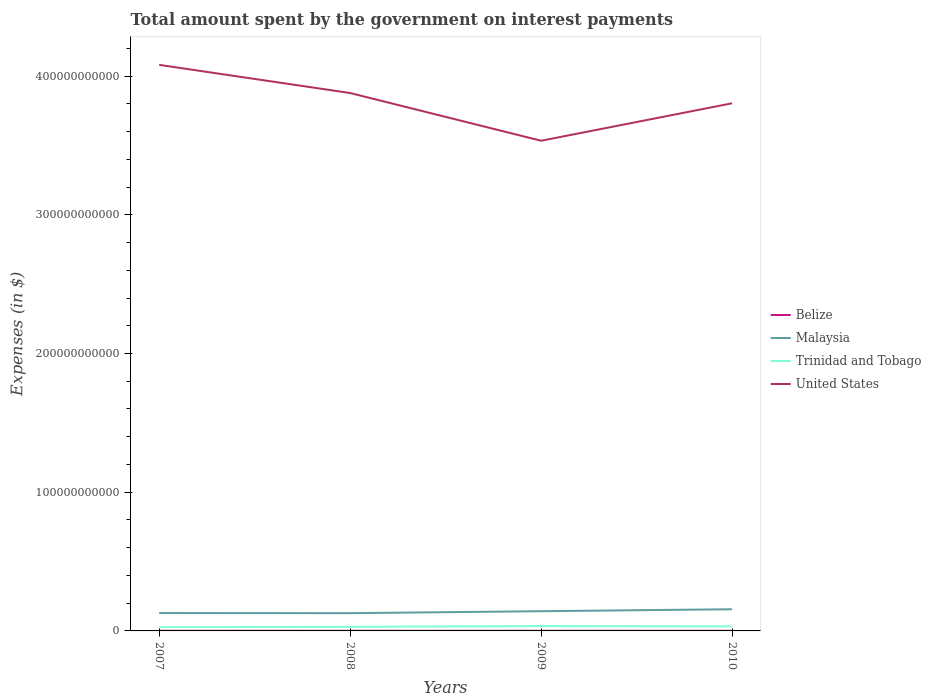Is the number of lines equal to the number of legend labels?
Ensure brevity in your answer.  Yes. Across all years, what is the maximum amount spent on interest payments by the government in Trinidad and Tobago?
Your answer should be very brief. 2.70e+09. In which year was the amount spent on interest payments by the government in United States maximum?
Offer a terse response. 2009. What is the total amount spent on interest payments by the government in Malaysia in the graph?
Provide a succinct answer. -1.31e+09. What is the difference between the highest and the second highest amount spent on interest payments by the government in United States?
Keep it short and to the point. 5.47e+1. Is the amount spent on interest payments by the government in Trinidad and Tobago strictly greater than the amount spent on interest payments by the government in Malaysia over the years?
Give a very brief answer. Yes. How many years are there in the graph?
Your answer should be compact. 4. What is the difference between two consecutive major ticks on the Y-axis?
Give a very brief answer. 1.00e+11. Does the graph contain any zero values?
Provide a succinct answer. No. Where does the legend appear in the graph?
Keep it short and to the point. Center right. How many legend labels are there?
Offer a very short reply. 4. What is the title of the graph?
Make the answer very short. Total amount spent by the government on interest payments. What is the label or title of the Y-axis?
Offer a very short reply. Expenses (in $). What is the Expenses (in $) in Belize in 2007?
Provide a short and direct response. 1.11e+08. What is the Expenses (in $) in Malaysia in 2007?
Your answer should be very brief. 1.29e+1. What is the Expenses (in $) of Trinidad and Tobago in 2007?
Keep it short and to the point. 2.70e+09. What is the Expenses (in $) of United States in 2007?
Offer a very short reply. 4.08e+11. What is the Expenses (in $) in Belize in 2008?
Your answer should be compact. 1.02e+08. What is the Expenses (in $) of Malaysia in 2008?
Offer a very short reply. 1.28e+1. What is the Expenses (in $) of Trinidad and Tobago in 2008?
Offer a terse response. 2.97e+09. What is the Expenses (in $) of United States in 2008?
Provide a short and direct response. 3.88e+11. What is the Expenses (in $) of Belize in 2009?
Your response must be concise. 9.58e+07. What is the Expenses (in $) in Malaysia in 2009?
Make the answer very short. 1.42e+1. What is the Expenses (in $) of Trinidad and Tobago in 2009?
Your answer should be compact. 3.50e+09. What is the Expenses (in $) in United States in 2009?
Keep it short and to the point. 3.53e+11. What is the Expenses (in $) in Belize in 2010?
Offer a terse response. 1.03e+08. What is the Expenses (in $) in Malaysia in 2010?
Provide a succinct answer. 1.56e+1. What is the Expenses (in $) of Trinidad and Tobago in 2010?
Your answer should be compact. 3.29e+09. What is the Expenses (in $) in United States in 2010?
Provide a short and direct response. 3.80e+11. Across all years, what is the maximum Expenses (in $) of Belize?
Make the answer very short. 1.11e+08. Across all years, what is the maximum Expenses (in $) of Malaysia?
Keep it short and to the point. 1.56e+1. Across all years, what is the maximum Expenses (in $) of Trinidad and Tobago?
Your response must be concise. 3.50e+09. Across all years, what is the maximum Expenses (in $) in United States?
Make the answer very short. 4.08e+11. Across all years, what is the minimum Expenses (in $) in Belize?
Give a very brief answer. 9.58e+07. Across all years, what is the minimum Expenses (in $) in Malaysia?
Your response must be concise. 1.28e+1. Across all years, what is the minimum Expenses (in $) of Trinidad and Tobago?
Keep it short and to the point. 2.70e+09. Across all years, what is the minimum Expenses (in $) in United States?
Ensure brevity in your answer.  3.53e+11. What is the total Expenses (in $) of Belize in the graph?
Provide a succinct answer. 4.13e+08. What is the total Expenses (in $) of Malaysia in the graph?
Offer a terse response. 5.56e+1. What is the total Expenses (in $) of Trinidad and Tobago in the graph?
Make the answer very short. 1.25e+1. What is the total Expenses (in $) of United States in the graph?
Provide a short and direct response. 1.53e+12. What is the difference between the Expenses (in $) in Belize in 2007 and that in 2008?
Give a very brief answer. 8.84e+06. What is the difference between the Expenses (in $) of Malaysia in 2007 and that in 2008?
Your answer should be very brief. 1.14e+08. What is the difference between the Expenses (in $) in Trinidad and Tobago in 2007 and that in 2008?
Make the answer very short. -2.69e+08. What is the difference between the Expenses (in $) of United States in 2007 and that in 2008?
Your answer should be very brief. 2.03e+1. What is the difference between the Expenses (in $) of Belize in 2007 and that in 2009?
Offer a terse response. 1.54e+07. What is the difference between the Expenses (in $) in Malaysia in 2007 and that in 2009?
Ensure brevity in your answer.  -1.31e+09. What is the difference between the Expenses (in $) in Trinidad and Tobago in 2007 and that in 2009?
Provide a short and direct response. -8.02e+08. What is the difference between the Expenses (in $) in United States in 2007 and that in 2009?
Offer a terse response. 5.47e+1. What is the difference between the Expenses (in $) of Belize in 2007 and that in 2010?
Your answer should be very brief. 7.81e+06. What is the difference between the Expenses (in $) of Malaysia in 2007 and that in 2010?
Provide a succinct answer. -2.71e+09. What is the difference between the Expenses (in $) in Trinidad and Tobago in 2007 and that in 2010?
Your response must be concise. -5.92e+08. What is the difference between the Expenses (in $) in United States in 2007 and that in 2010?
Give a very brief answer. 2.77e+1. What is the difference between the Expenses (in $) of Belize in 2008 and that in 2009?
Your response must be concise. 6.55e+06. What is the difference between the Expenses (in $) of Malaysia in 2008 and that in 2009?
Your answer should be very brief. -1.42e+09. What is the difference between the Expenses (in $) of Trinidad and Tobago in 2008 and that in 2009?
Give a very brief answer. -5.33e+08. What is the difference between the Expenses (in $) of United States in 2008 and that in 2009?
Your answer should be very brief. 3.44e+1. What is the difference between the Expenses (in $) in Belize in 2008 and that in 2010?
Make the answer very short. -1.03e+06. What is the difference between the Expenses (in $) of Malaysia in 2008 and that in 2010?
Your answer should be compact. -2.82e+09. What is the difference between the Expenses (in $) of Trinidad and Tobago in 2008 and that in 2010?
Offer a terse response. -3.23e+08. What is the difference between the Expenses (in $) of United States in 2008 and that in 2010?
Your response must be concise. 7.40e+09. What is the difference between the Expenses (in $) in Belize in 2009 and that in 2010?
Offer a very short reply. -7.59e+06. What is the difference between the Expenses (in $) in Malaysia in 2009 and that in 2010?
Make the answer very short. -1.40e+09. What is the difference between the Expenses (in $) of Trinidad and Tobago in 2009 and that in 2010?
Your response must be concise. 2.10e+08. What is the difference between the Expenses (in $) in United States in 2009 and that in 2010?
Offer a terse response. -2.70e+1. What is the difference between the Expenses (in $) in Belize in 2007 and the Expenses (in $) in Malaysia in 2008?
Ensure brevity in your answer.  -1.27e+1. What is the difference between the Expenses (in $) in Belize in 2007 and the Expenses (in $) in Trinidad and Tobago in 2008?
Give a very brief answer. -2.86e+09. What is the difference between the Expenses (in $) of Belize in 2007 and the Expenses (in $) of United States in 2008?
Your response must be concise. -3.88e+11. What is the difference between the Expenses (in $) of Malaysia in 2007 and the Expenses (in $) of Trinidad and Tobago in 2008?
Offer a terse response. 9.94e+09. What is the difference between the Expenses (in $) of Malaysia in 2007 and the Expenses (in $) of United States in 2008?
Give a very brief answer. -3.75e+11. What is the difference between the Expenses (in $) in Trinidad and Tobago in 2007 and the Expenses (in $) in United States in 2008?
Provide a short and direct response. -3.85e+11. What is the difference between the Expenses (in $) in Belize in 2007 and the Expenses (in $) in Malaysia in 2009?
Your answer should be compact. -1.41e+1. What is the difference between the Expenses (in $) in Belize in 2007 and the Expenses (in $) in Trinidad and Tobago in 2009?
Give a very brief answer. -3.39e+09. What is the difference between the Expenses (in $) in Belize in 2007 and the Expenses (in $) in United States in 2009?
Provide a short and direct response. -3.53e+11. What is the difference between the Expenses (in $) of Malaysia in 2007 and the Expenses (in $) of Trinidad and Tobago in 2009?
Your response must be concise. 9.41e+09. What is the difference between the Expenses (in $) of Malaysia in 2007 and the Expenses (in $) of United States in 2009?
Your answer should be very brief. -3.40e+11. What is the difference between the Expenses (in $) in Trinidad and Tobago in 2007 and the Expenses (in $) in United States in 2009?
Offer a terse response. -3.51e+11. What is the difference between the Expenses (in $) in Belize in 2007 and the Expenses (in $) in Malaysia in 2010?
Offer a very short reply. -1.55e+1. What is the difference between the Expenses (in $) of Belize in 2007 and the Expenses (in $) of Trinidad and Tobago in 2010?
Provide a succinct answer. -3.18e+09. What is the difference between the Expenses (in $) in Belize in 2007 and the Expenses (in $) in United States in 2010?
Offer a very short reply. -3.80e+11. What is the difference between the Expenses (in $) in Malaysia in 2007 and the Expenses (in $) in Trinidad and Tobago in 2010?
Offer a very short reply. 9.62e+09. What is the difference between the Expenses (in $) in Malaysia in 2007 and the Expenses (in $) in United States in 2010?
Your answer should be compact. -3.67e+11. What is the difference between the Expenses (in $) of Trinidad and Tobago in 2007 and the Expenses (in $) of United States in 2010?
Provide a succinct answer. -3.78e+11. What is the difference between the Expenses (in $) of Belize in 2008 and the Expenses (in $) of Malaysia in 2009?
Offer a terse response. -1.41e+1. What is the difference between the Expenses (in $) in Belize in 2008 and the Expenses (in $) in Trinidad and Tobago in 2009?
Give a very brief answer. -3.40e+09. What is the difference between the Expenses (in $) of Belize in 2008 and the Expenses (in $) of United States in 2009?
Your answer should be very brief. -3.53e+11. What is the difference between the Expenses (in $) in Malaysia in 2008 and the Expenses (in $) in Trinidad and Tobago in 2009?
Offer a terse response. 9.30e+09. What is the difference between the Expenses (in $) of Malaysia in 2008 and the Expenses (in $) of United States in 2009?
Your response must be concise. -3.41e+11. What is the difference between the Expenses (in $) of Trinidad and Tobago in 2008 and the Expenses (in $) of United States in 2009?
Ensure brevity in your answer.  -3.50e+11. What is the difference between the Expenses (in $) of Belize in 2008 and the Expenses (in $) of Malaysia in 2010?
Offer a very short reply. -1.55e+1. What is the difference between the Expenses (in $) in Belize in 2008 and the Expenses (in $) in Trinidad and Tobago in 2010?
Your answer should be very brief. -3.19e+09. What is the difference between the Expenses (in $) of Belize in 2008 and the Expenses (in $) of United States in 2010?
Keep it short and to the point. -3.80e+11. What is the difference between the Expenses (in $) of Malaysia in 2008 and the Expenses (in $) of Trinidad and Tobago in 2010?
Provide a succinct answer. 9.51e+09. What is the difference between the Expenses (in $) in Malaysia in 2008 and the Expenses (in $) in United States in 2010?
Make the answer very short. -3.68e+11. What is the difference between the Expenses (in $) of Trinidad and Tobago in 2008 and the Expenses (in $) of United States in 2010?
Offer a very short reply. -3.77e+11. What is the difference between the Expenses (in $) in Belize in 2009 and the Expenses (in $) in Malaysia in 2010?
Give a very brief answer. -1.55e+1. What is the difference between the Expenses (in $) in Belize in 2009 and the Expenses (in $) in Trinidad and Tobago in 2010?
Your answer should be very brief. -3.19e+09. What is the difference between the Expenses (in $) of Belize in 2009 and the Expenses (in $) of United States in 2010?
Provide a succinct answer. -3.80e+11. What is the difference between the Expenses (in $) in Malaysia in 2009 and the Expenses (in $) in Trinidad and Tobago in 2010?
Your answer should be very brief. 1.09e+1. What is the difference between the Expenses (in $) of Malaysia in 2009 and the Expenses (in $) of United States in 2010?
Provide a short and direct response. -3.66e+11. What is the difference between the Expenses (in $) of Trinidad and Tobago in 2009 and the Expenses (in $) of United States in 2010?
Keep it short and to the point. -3.77e+11. What is the average Expenses (in $) in Belize per year?
Keep it short and to the point. 1.03e+08. What is the average Expenses (in $) of Malaysia per year?
Give a very brief answer. 1.39e+1. What is the average Expenses (in $) of Trinidad and Tobago per year?
Keep it short and to the point. 3.11e+09. What is the average Expenses (in $) in United States per year?
Your answer should be compact. 3.82e+11. In the year 2007, what is the difference between the Expenses (in $) of Belize and Expenses (in $) of Malaysia?
Give a very brief answer. -1.28e+1. In the year 2007, what is the difference between the Expenses (in $) in Belize and Expenses (in $) in Trinidad and Tobago?
Your response must be concise. -2.59e+09. In the year 2007, what is the difference between the Expenses (in $) of Belize and Expenses (in $) of United States?
Keep it short and to the point. -4.08e+11. In the year 2007, what is the difference between the Expenses (in $) in Malaysia and Expenses (in $) in Trinidad and Tobago?
Make the answer very short. 1.02e+1. In the year 2007, what is the difference between the Expenses (in $) of Malaysia and Expenses (in $) of United States?
Keep it short and to the point. -3.95e+11. In the year 2007, what is the difference between the Expenses (in $) of Trinidad and Tobago and Expenses (in $) of United States?
Provide a short and direct response. -4.05e+11. In the year 2008, what is the difference between the Expenses (in $) in Belize and Expenses (in $) in Malaysia?
Provide a succinct answer. -1.27e+1. In the year 2008, what is the difference between the Expenses (in $) in Belize and Expenses (in $) in Trinidad and Tobago?
Your answer should be very brief. -2.86e+09. In the year 2008, what is the difference between the Expenses (in $) of Belize and Expenses (in $) of United States?
Offer a very short reply. -3.88e+11. In the year 2008, what is the difference between the Expenses (in $) in Malaysia and Expenses (in $) in Trinidad and Tobago?
Your answer should be very brief. 9.83e+09. In the year 2008, what is the difference between the Expenses (in $) in Malaysia and Expenses (in $) in United States?
Give a very brief answer. -3.75e+11. In the year 2008, what is the difference between the Expenses (in $) of Trinidad and Tobago and Expenses (in $) of United States?
Offer a very short reply. -3.85e+11. In the year 2009, what is the difference between the Expenses (in $) in Belize and Expenses (in $) in Malaysia?
Your answer should be very brief. -1.41e+1. In the year 2009, what is the difference between the Expenses (in $) of Belize and Expenses (in $) of Trinidad and Tobago?
Make the answer very short. -3.40e+09. In the year 2009, what is the difference between the Expenses (in $) of Belize and Expenses (in $) of United States?
Make the answer very short. -3.53e+11. In the year 2009, what is the difference between the Expenses (in $) in Malaysia and Expenses (in $) in Trinidad and Tobago?
Keep it short and to the point. 1.07e+1. In the year 2009, what is the difference between the Expenses (in $) in Malaysia and Expenses (in $) in United States?
Make the answer very short. -3.39e+11. In the year 2009, what is the difference between the Expenses (in $) of Trinidad and Tobago and Expenses (in $) of United States?
Your answer should be very brief. -3.50e+11. In the year 2010, what is the difference between the Expenses (in $) of Belize and Expenses (in $) of Malaysia?
Offer a terse response. -1.55e+1. In the year 2010, what is the difference between the Expenses (in $) in Belize and Expenses (in $) in Trinidad and Tobago?
Make the answer very short. -3.19e+09. In the year 2010, what is the difference between the Expenses (in $) of Belize and Expenses (in $) of United States?
Your response must be concise. -3.80e+11. In the year 2010, what is the difference between the Expenses (in $) of Malaysia and Expenses (in $) of Trinidad and Tobago?
Keep it short and to the point. 1.23e+1. In the year 2010, what is the difference between the Expenses (in $) in Malaysia and Expenses (in $) in United States?
Offer a terse response. -3.65e+11. In the year 2010, what is the difference between the Expenses (in $) of Trinidad and Tobago and Expenses (in $) of United States?
Provide a succinct answer. -3.77e+11. What is the ratio of the Expenses (in $) of Belize in 2007 to that in 2008?
Offer a terse response. 1.09. What is the ratio of the Expenses (in $) in Malaysia in 2007 to that in 2008?
Give a very brief answer. 1.01. What is the ratio of the Expenses (in $) of Trinidad and Tobago in 2007 to that in 2008?
Ensure brevity in your answer.  0.91. What is the ratio of the Expenses (in $) of United States in 2007 to that in 2008?
Your response must be concise. 1.05. What is the ratio of the Expenses (in $) in Belize in 2007 to that in 2009?
Offer a terse response. 1.16. What is the ratio of the Expenses (in $) in Malaysia in 2007 to that in 2009?
Provide a succinct answer. 0.91. What is the ratio of the Expenses (in $) of Trinidad and Tobago in 2007 to that in 2009?
Make the answer very short. 0.77. What is the ratio of the Expenses (in $) of United States in 2007 to that in 2009?
Your answer should be compact. 1.15. What is the ratio of the Expenses (in $) of Belize in 2007 to that in 2010?
Provide a succinct answer. 1.08. What is the ratio of the Expenses (in $) in Malaysia in 2007 to that in 2010?
Provide a succinct answer. 0.83. What is the ratio of the Expenses (in $) of Trinidad and Tobago in 2007 to that in 2010?
Ensure brevity in your answer.  0.82. What is the ratio of the Expenses (in $) of United States in 2007 to that in 2010?
Keep it short and to the point. 1.07. What is the ratio of the Expenses (in $) of Belize in 2008 to that in 2009?
Provide a succinct answer. 1.07. What is the ratio of the Expenses (in $) of Malaysia in 2008 to that in 2009?
Your response must be concise. 0.9. What is the ratio of the Expenses (in $) of Trinidad and Tobago in 2008 to that in 2009?
Ensure brevity in your answer.  0.85. What is the ratio of the Expenses (in $) in United States in 2008 to that in 2009?
Make the answer very short. 1.1. What is the ratio of the Expenses (in $) in Malaysia in 2008 to that in 2010?
Ensure brevity in your answer.  0.82. What is the ratio of the Expenses (in $) of Trinidad and Tobago in 2008 to that in 2010?
Provide a short and direct response. 0.9. What is the ratio of the Expenses (in $) of United States in 2008 to that in 2010?
Your response must be concise. 1.02. What is the ratio of the Expenses (in $) in Belize in 2009 to that in 2010?
Keep it short and to the point. 0.93. What is the ratio of the Expenses (in $) of Malaysia in 2009 to that in 2010?
Offer a very short reply. 0.91. What is the ratio of the Expenses (in $) in Trinidad and Tobago in 2009 to that in 2010?
Provide a short and direct response. 1.06. What is the ratio of the Expenses (in $) of United States in 2009 to that in 2010?
Offer a very short reply. 0.93. What is the difference between the highest and the second highest Expenses (in $) of Belize?
Ensure brevity in your answer.  7.81e+06. What is the difference between the highest and the second highest Expenses (in $) in Malaysia?
Your answer should be very brief. 1.40e+09. What is the difference between the highest and the second highest Expenses (in $) in Trinidad and Tobago?
Give a very brief answer. 2.10e+08. What is the difference between the highest and the second highest Expenses (in $) of United States?
Offer a terse response. 2.03e+1. What is the difference between the highest and the lowest Expenses (in $) in Belize?
Keep it short and to the point. 1.54e+07. What is the difference between the highest and the lowest Expenses (in $) of Malaysia?
Offer a very short reply. 2.82e+09. What is the difference between the highest and the lowest Expenses (in $) in Trinidad and Tobago?
Offer a very short reply. 8.02e+08. What is the difference between the highest and the lowest Expenses (in $) of United States?
Your answer should be very brief. 5.47e+1. 